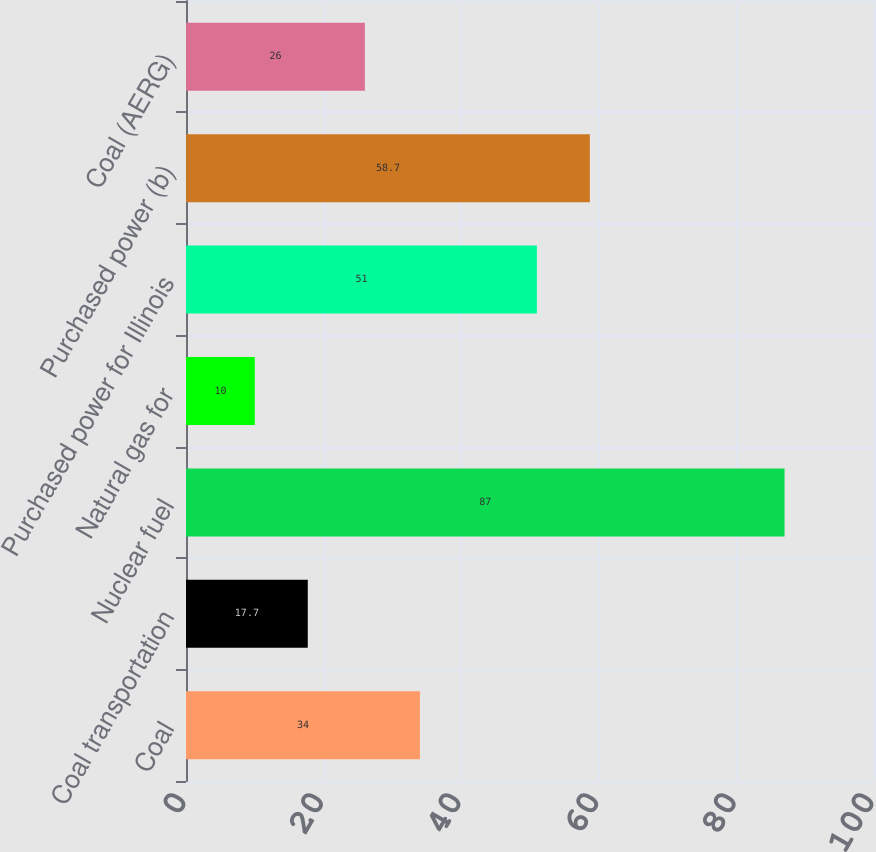Convert chart. <chart><loc_0><loc_0><loc_500><loc_500><bar_chart><fcel>Coal<fcel>Coal transportation<fcel>Nuclear fuel<fcel>Natural gas for<fcel>Purchased power for Illinois<fcel>Purchased power (b)<fcel>Coal (AERG)<nl><fcel>34<fcel>17.7<fcel>87<fcel>10<fcel>51<fcel>58.7<fcel>26<nl></chart> 